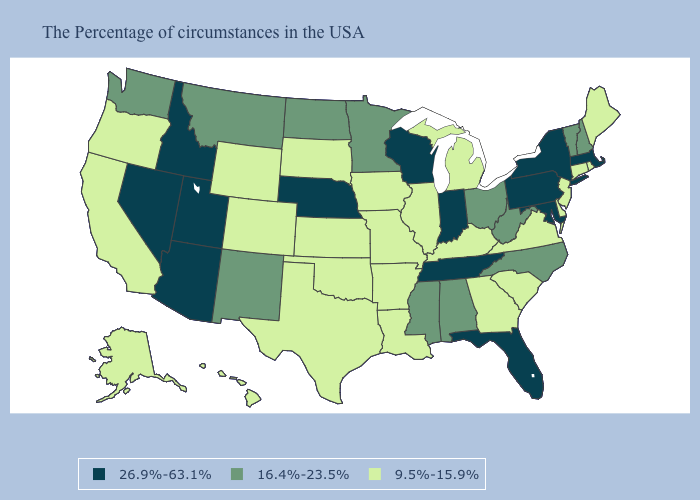Does South Dakota have the highest value in the MidWest?
Answer briefly. No. Name the states that have a value in the range 16.4%-23.5%?
Short answer required. New Hampshire, Vermont, North Carolina, West Virginia, Ohio, Alabama, Mississippi, Minnesota, North Dakota, New Mexico, Montana, Washington. Does the map have missing data?
Quick response, please. No. Does the first symbol in the legend represent the smallest category?
Give a very brief answer. No. Does the map have missing data?
Quick response, please. No. What is the value of Washington?
Short answer required. 16.4%-23.5%. Name the states that have a value in the range 16.4%-23.5%?
Answer briefly. New Hampshire, Vermont, North Carolina, West Virginia, Ohio, Alabama, Mississippi, Minnesota, North Dakota, New Mexico, Montana, Washington. What is the value of Wisconsin?
Answer briefly. 26.9%-63.1%. Among the states that border Massachusetts , which have the lowest value?
Give a very brief answer. Rhode Island, Connecticut. How many symbols are there in the legend?
Be succinct. 3. Does Maryland have the highest value in the South?
Keep it brief. Yes. Name the states that have a value in the range 9.5%-15.9%?
Concise answer only. Maine, Rhode Island, Connecticut, New Jersey, Delaware, Virginia, South Carolina, Georgia, Michigan, Kentucky, Illinois, Louisiana, Missouri, Arkansas, Iowa, Kansas, Oklahoma, Texas, South Dakota, Wyoming, Colorado, California, Oregon, Alaska, Hawaii. What is the highest value in the MidWest ?
Concise answer only. 26.9%-63.1%. What is the value of Tennessee?
Quick response, please. 26.9%-63.1%. What is the lowest value in the West?
Keep it brief. 9.5%-15.9%. 